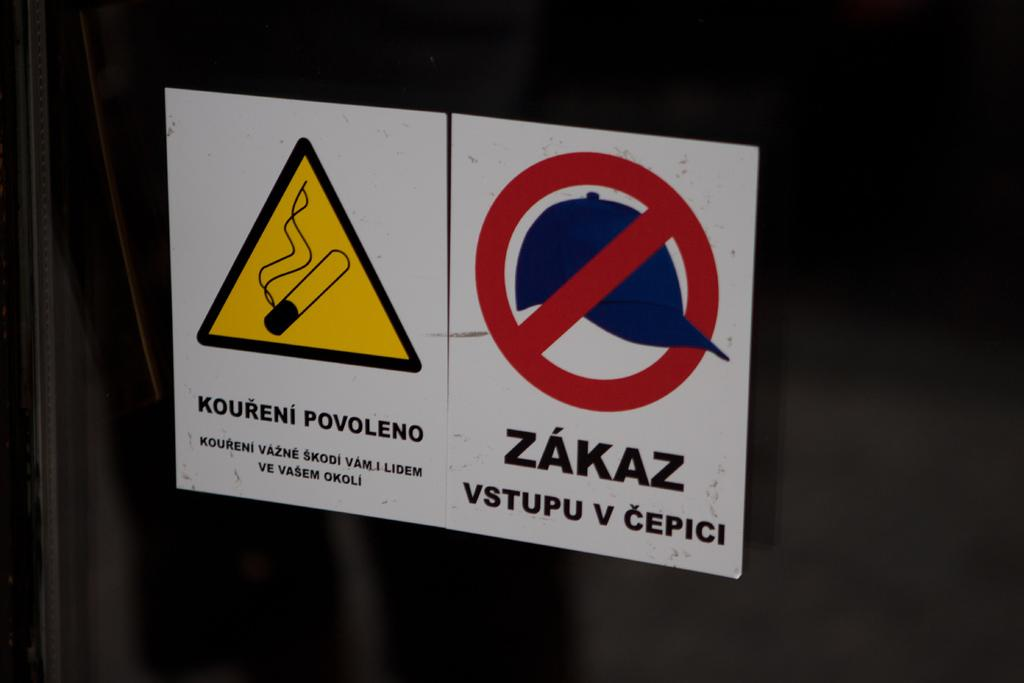<image>
Present a compact description of the photo's key features. two different warning signs sitting side by side written in russian. 